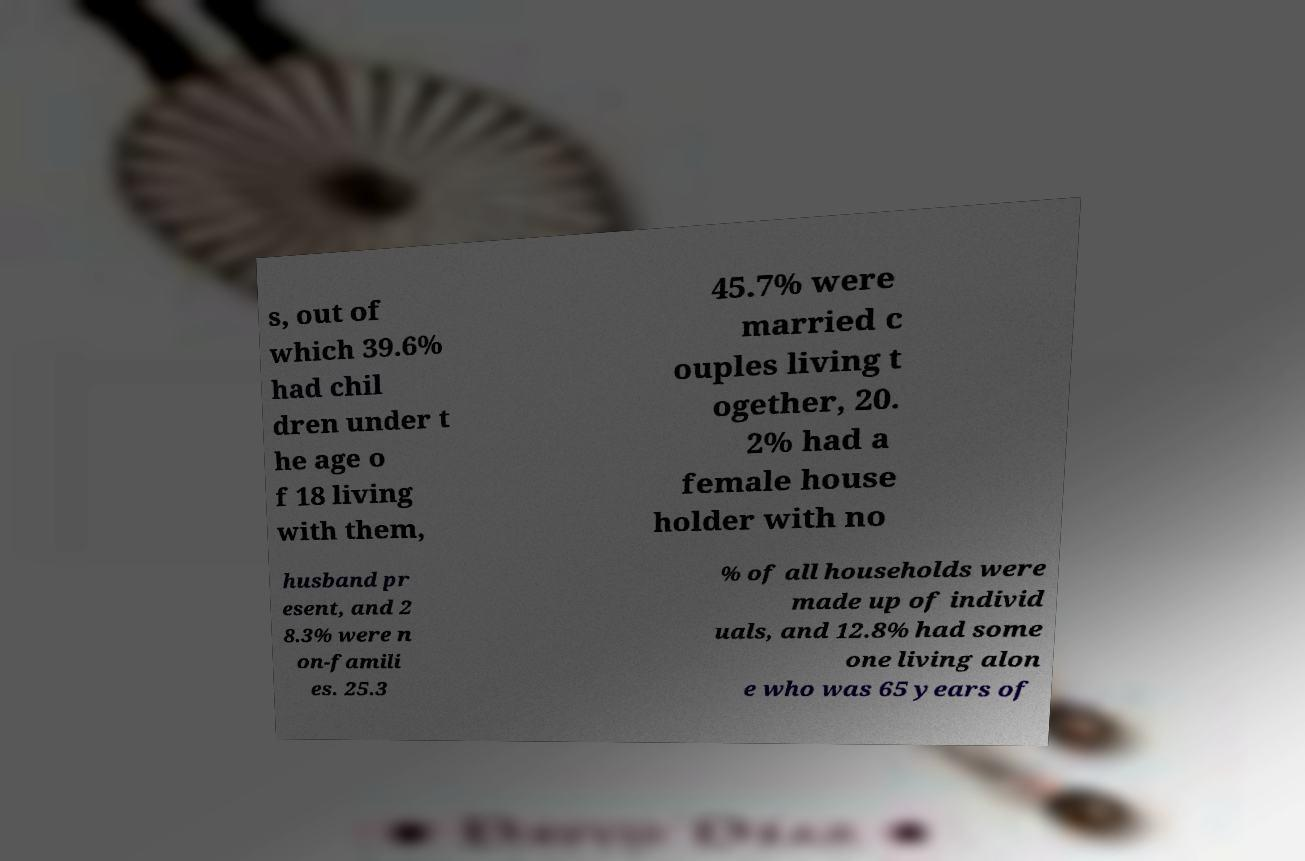Can you accurately transcribe the text from the provided image for me? s, out of which 39.6% had chil dren under t he age o f 18 living with them, 45.7% were married c ouples living t ogether, 20. 2% had a female house holder with no husband pr esent, and 2 8.3% were n on-famili es. 25.3 % of all households were made up of individ uals, and 12.8% had some one living alon e who was 65 years of 